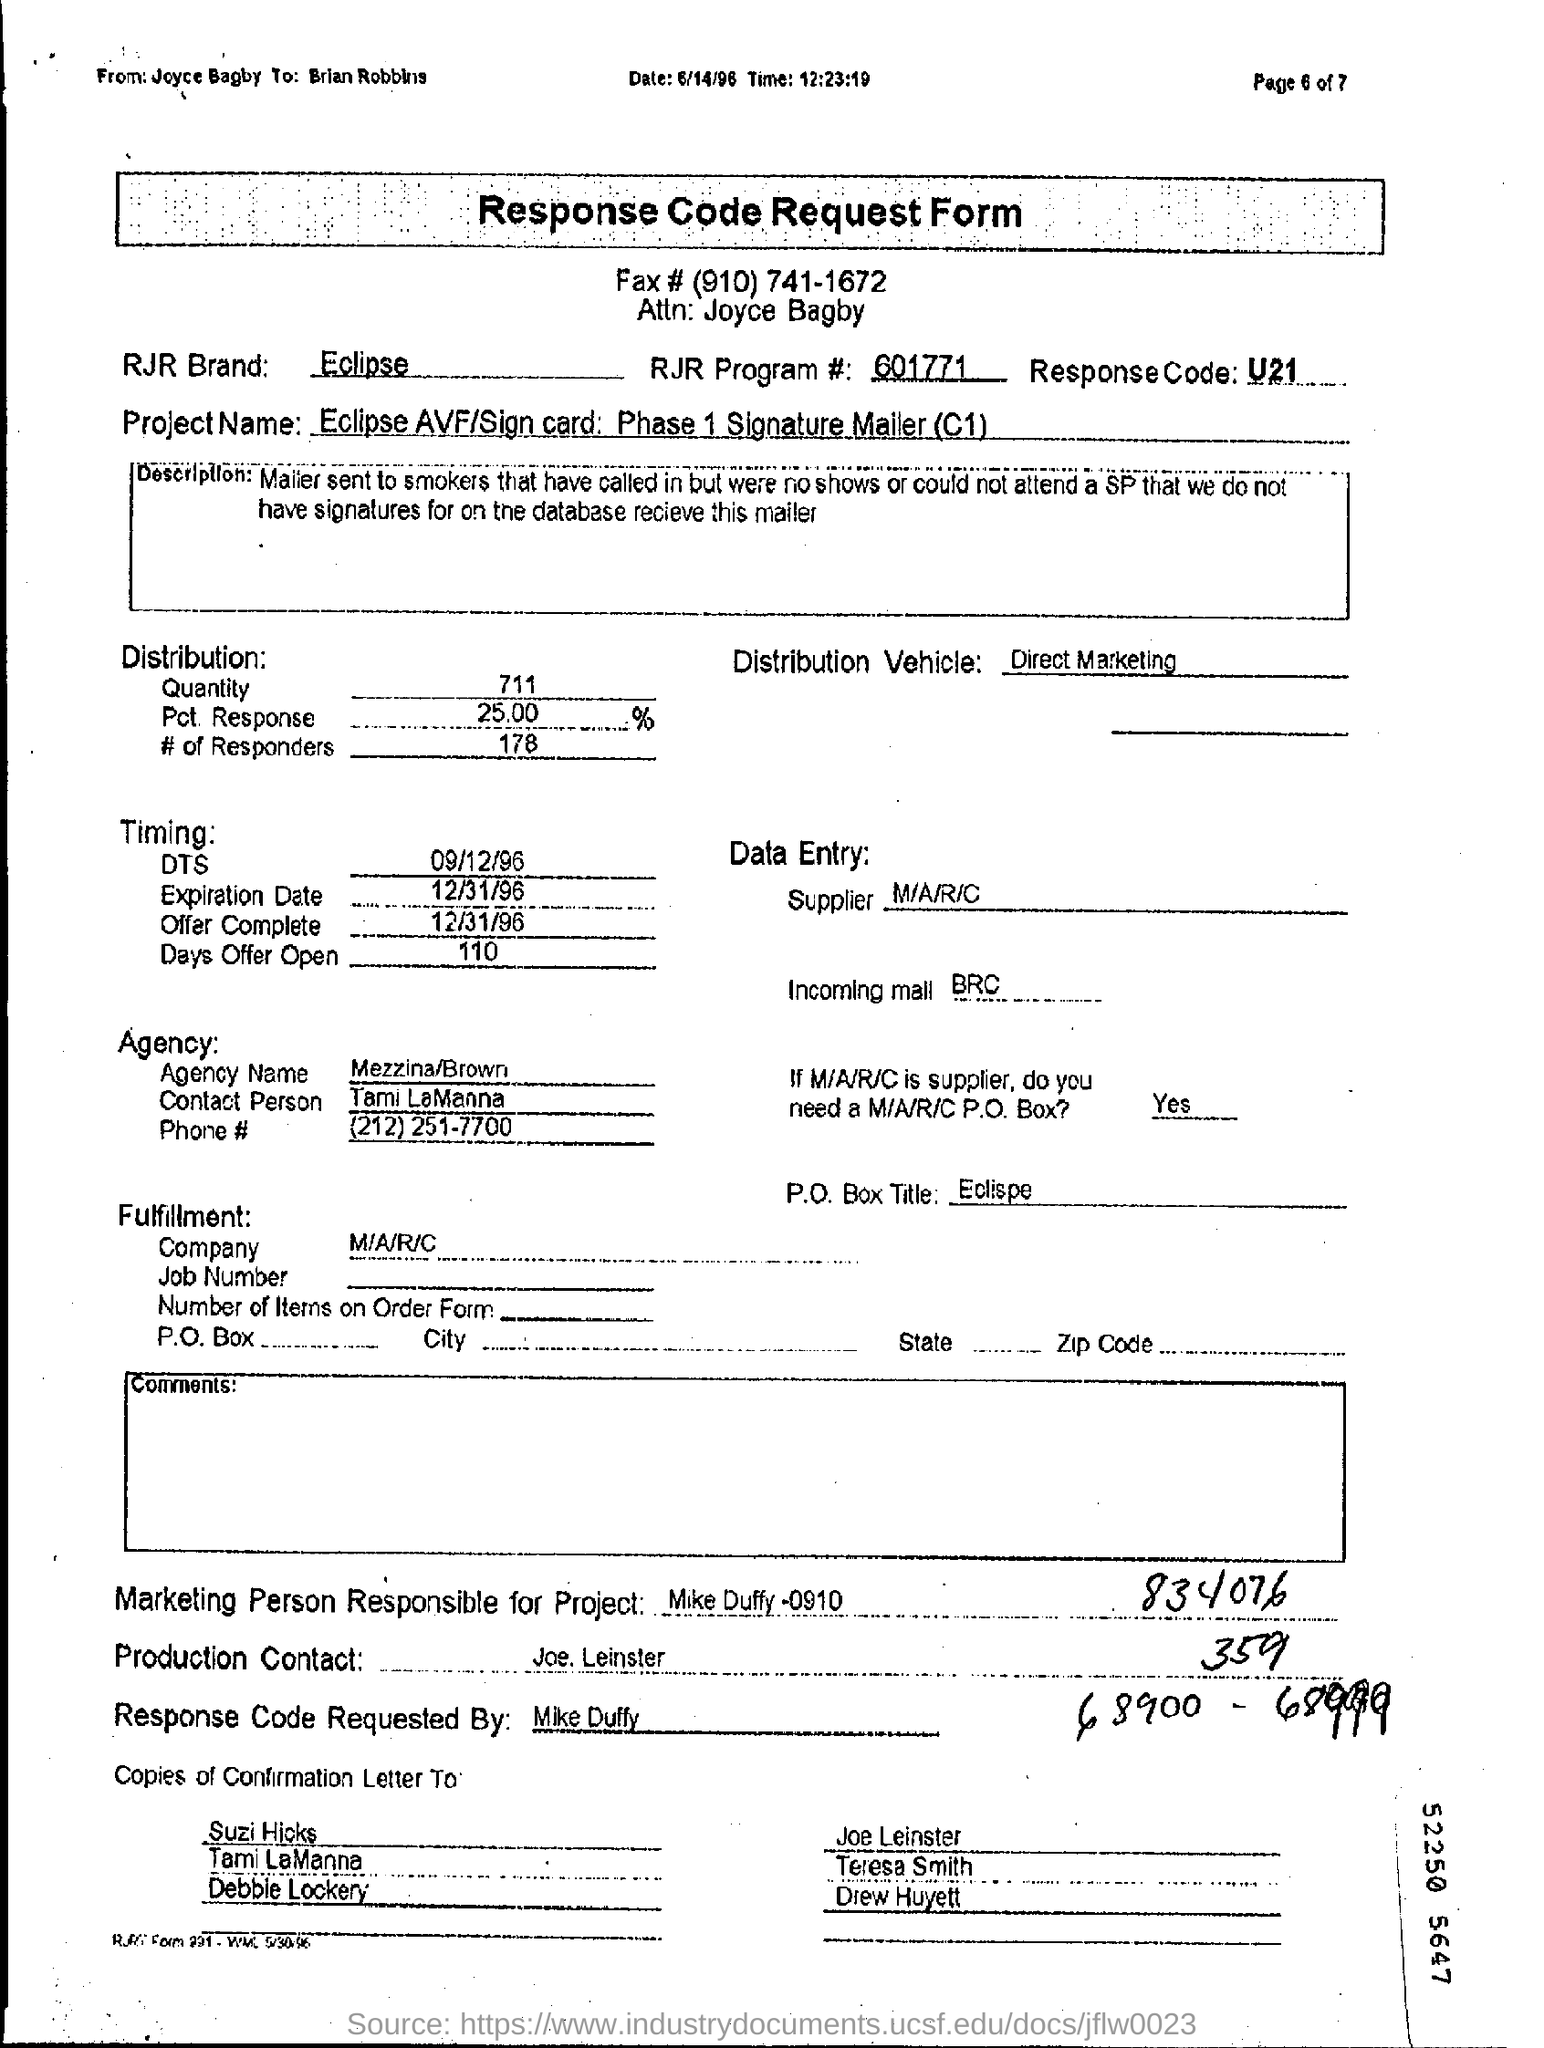NAME THE RJR BRAND ?
Keep it short and to the point. Eclipse. What is response code?
Keep it short and to the point. U21. 